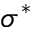Convert formula to latex. <formula><loc_0><loc_0><loc_500><loc_500>\sigma ^ { * }</formula> 